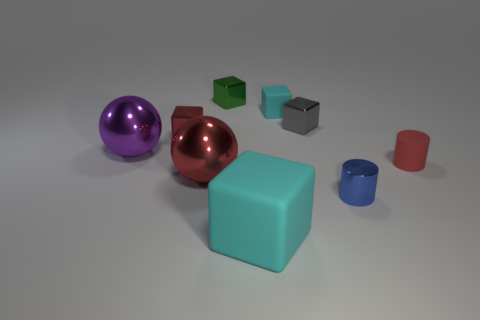Can you speculate on the purpose of these objects or what they represent? This collection of objects could represent a variety of concepts. The different materials and colors might symbolize diversity or variety. Their arrangement in space could also represent some form of balance or contrast between shapes and sizes. Given the simplicity and geometric nature of these objects, it's also possible they are part of a design or art concept, used to study the effects of color and form in three-dimensional space. 